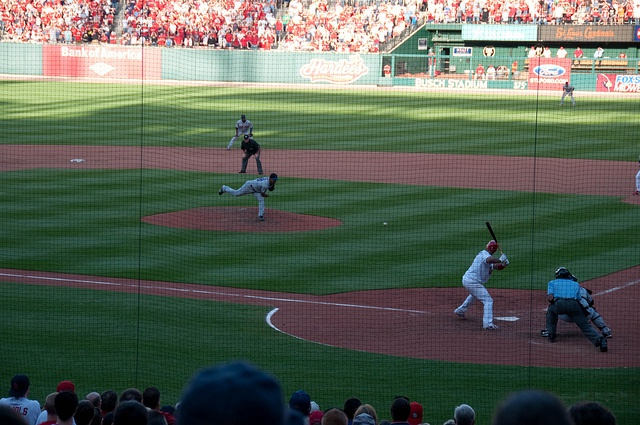Describe the objects in this image and their specific colors. I can see people in red, white, black, lightpink, and gray tones, people in red, black, navy, and blue tones, people in red, gray, black, and darkgray tones, people in black, darkblue, and red tones, and people in red, black, gray, blue, and navy tones in this image. 